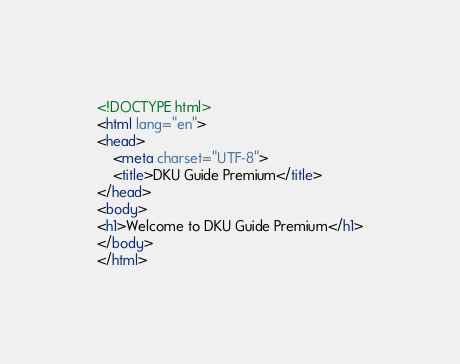Convert code to text. <code><loc_0><loc_0><loc_500><loc_500><_HTML_><!DOCTYPE html>
<html lang="en">
<head>
    <meta charset="UTF-8">
    <title>DKU Guide Premium</title>
</head>
<body>
<h1>Welcome to DKU Guide Premium</h1>
</body>
</html></code> 